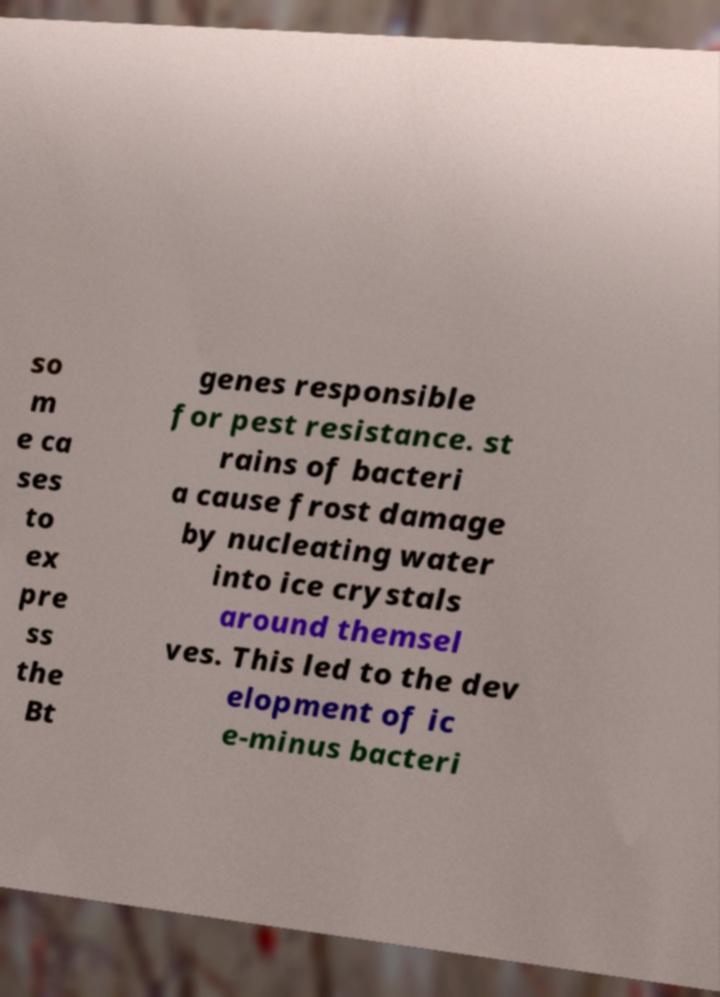Could you extract and type out the text from this image? so m e ca ses to ex pre ss the Bt genes responsible for pest resistance. st rains of bacteri a cause frost damage by nucleating water into ice crystals around themsel ves. This led to the dev elopment of ic e-minus bacteri 